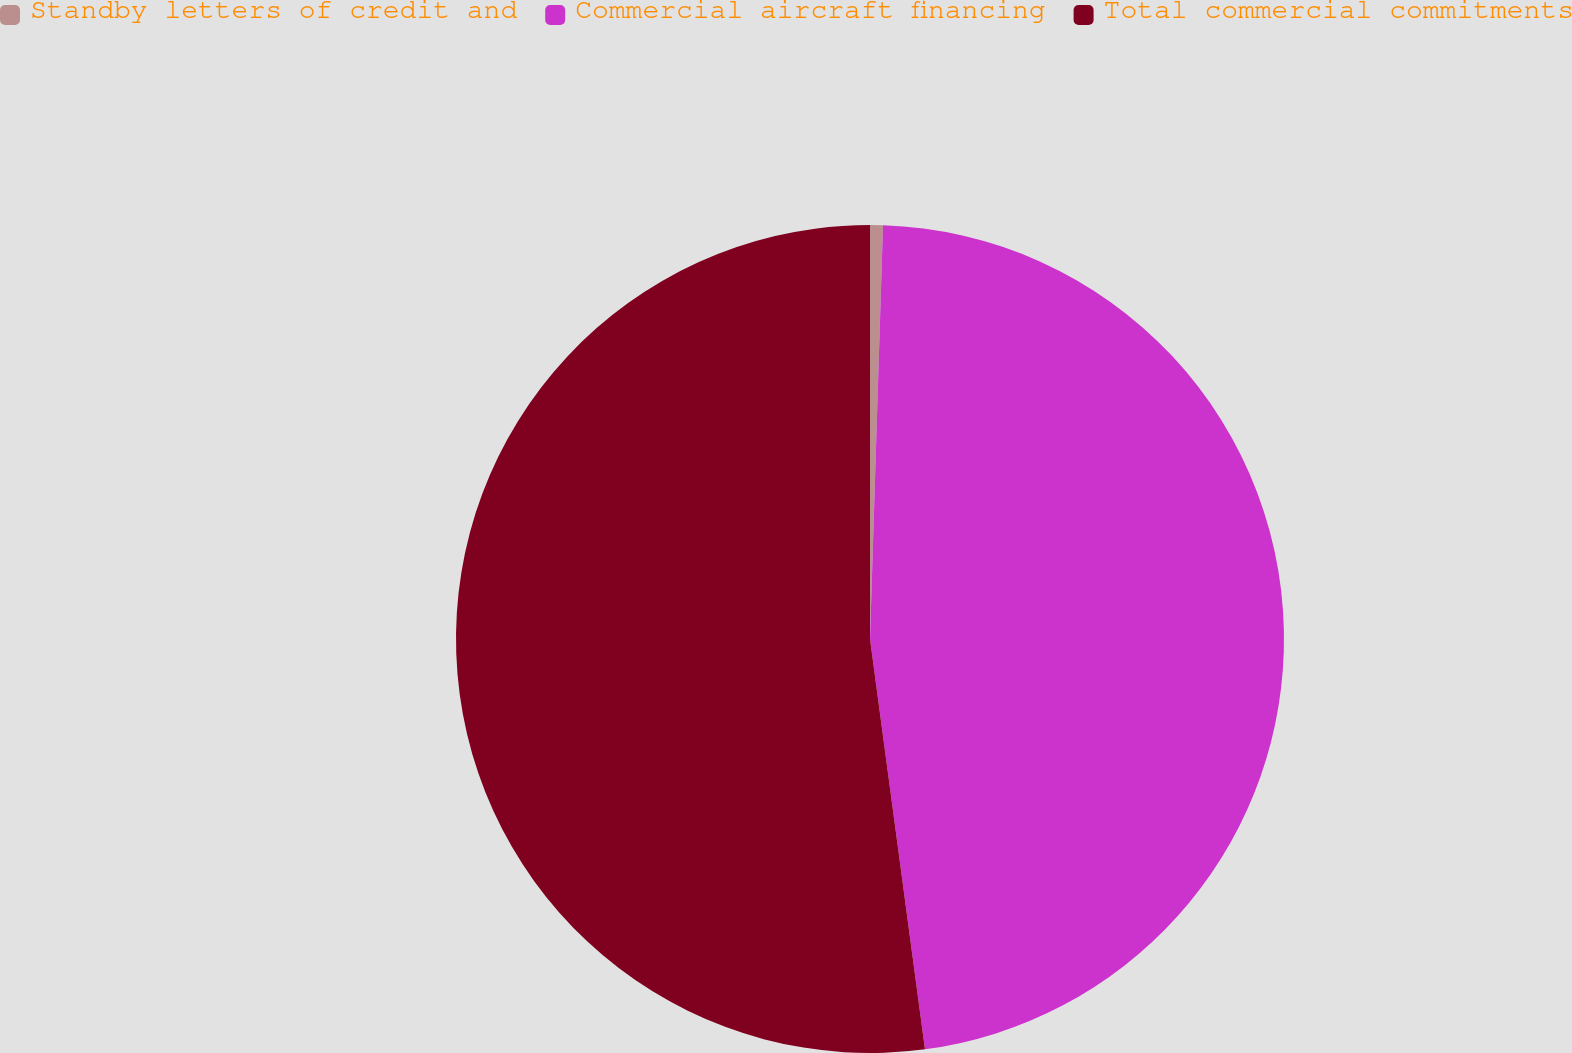Convert chart. <chart><loc_0><loc_0><loc_500><loc_500><pie_chart><fcel>Standby letters of credit and<fcel>Commercial aircraft financing<fcel>Total commercial commitments<nl><fcel>0.5%<fcel>47.38%<fcel>52.12%<nl></chart> 